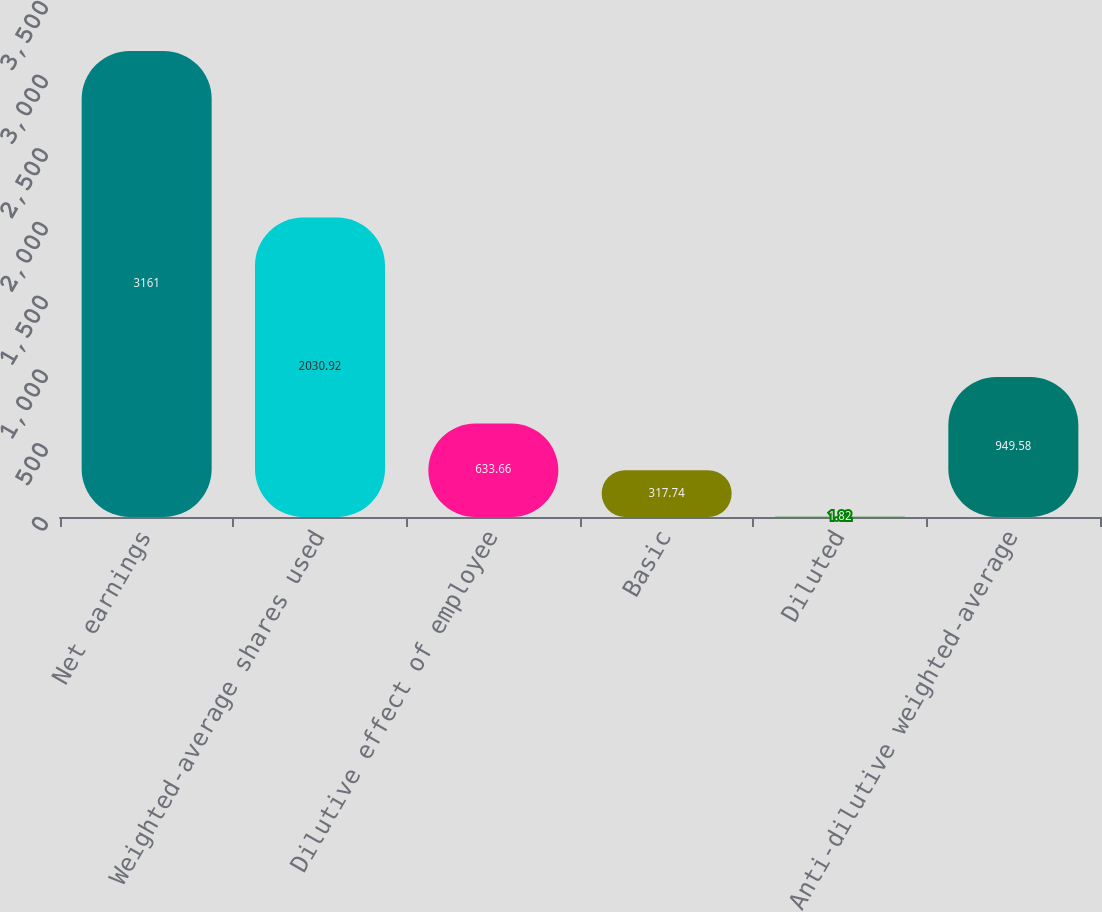Convert chart to OTSL. <chart><loc_0><loc_0><loc_500><loc_500><bar_chart><fcel>Net earnings<fcel>Weighted-average shares used<fcel>Dilutive effect of employee<fcel>Basic<fcel>Diluted<fcel>Anti-dilutive weighted-average<nl><fcel>3161<fcel>2030.92<fcel>633.66<fcel>317.74<fcel>1.82<fcel>949.58<nl></chart> 